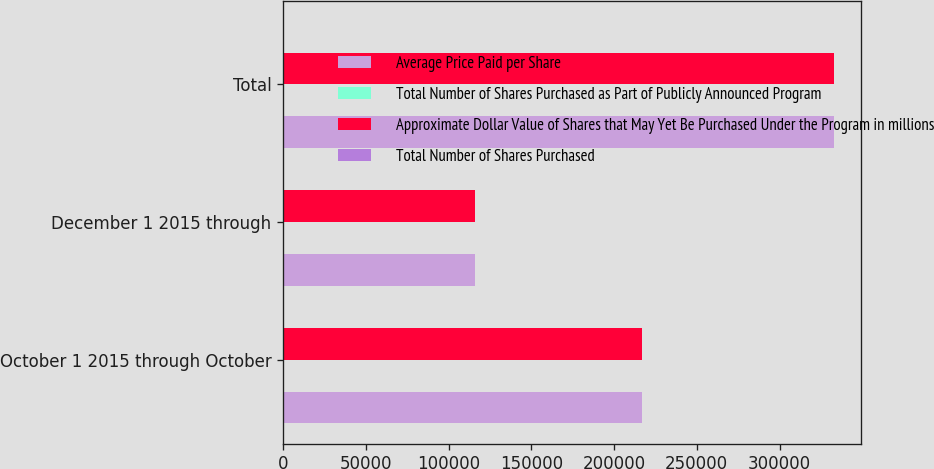Convert chart to OTSL. <chart><loc_0><loc_0><loc_500><loc_500><stacked_bar_chart><ecel><fcel>October 1 2015 through October<fcel>December 1 2015 through<fcel>Total<nl><fcel>Average Price Paid per Share<fcel>217026<fcel>115670<fcel>332696<nl><fcel>Total Number of Shares Purchased as Part of Publicly Announced Program<fcel>105.81<fcel>127.93<fcel>113.5<nl><fcel>Approximate Dollar Value of Shares that May Yet Be Purchased Under the Program in millions<fcel>217026<fcel>115670<fcel>332696<nl><fcel>Total Number of Shares Purchased<fcel>723<fcel>708.2<fcel>708.2<nl></chart> 